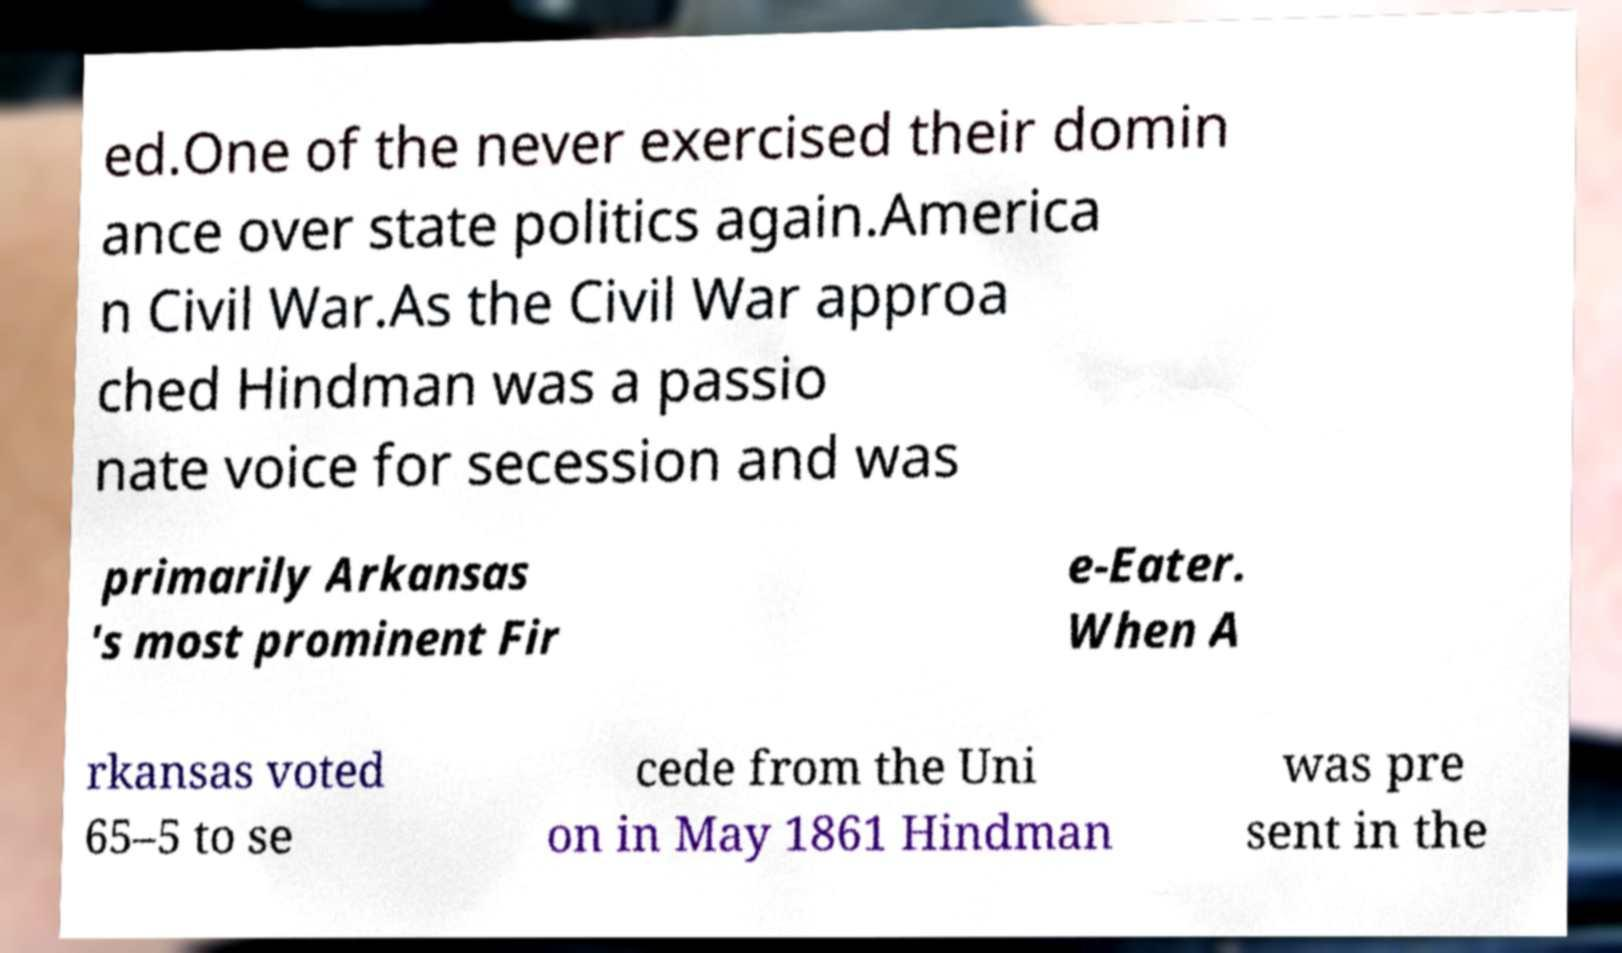Can you read and provide the text displayed in the image?This photo seems to have some interesting text. Can you extract and type it out for me? ed.One of the never exercised their domin ance over state politics again.America n Civil War.As the Civil War approa ched Hindman was a passio nate voice for secession and was primarily Arkansas 's most prominent Fir e-Eater. When A rkansas voted 65–5 to se cede from the Uni on in May 1861 Hindman was pre sent in the 